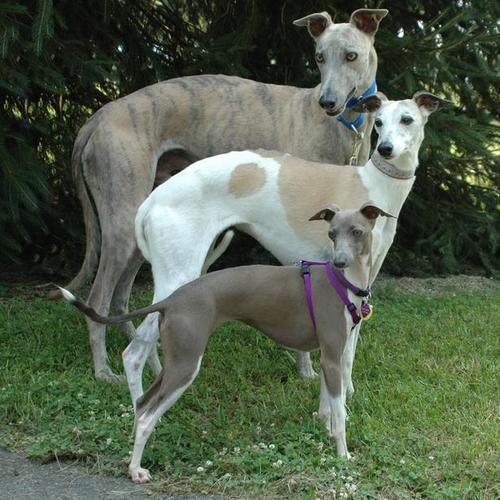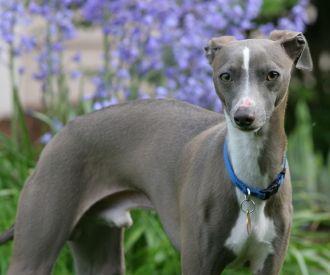The first image is the image on the left, the second image is the image on the right. Considering the images on both sides, is "There are two dogs in total and one of them is wearing a collar." valid? Answer yes or no. No. The first image is the image on the left, the second image is the image on the right. Analyze the images presented: Is the assertion "The dog in the right image has a red collar around its neck." valid? Answer yes or no. No. 